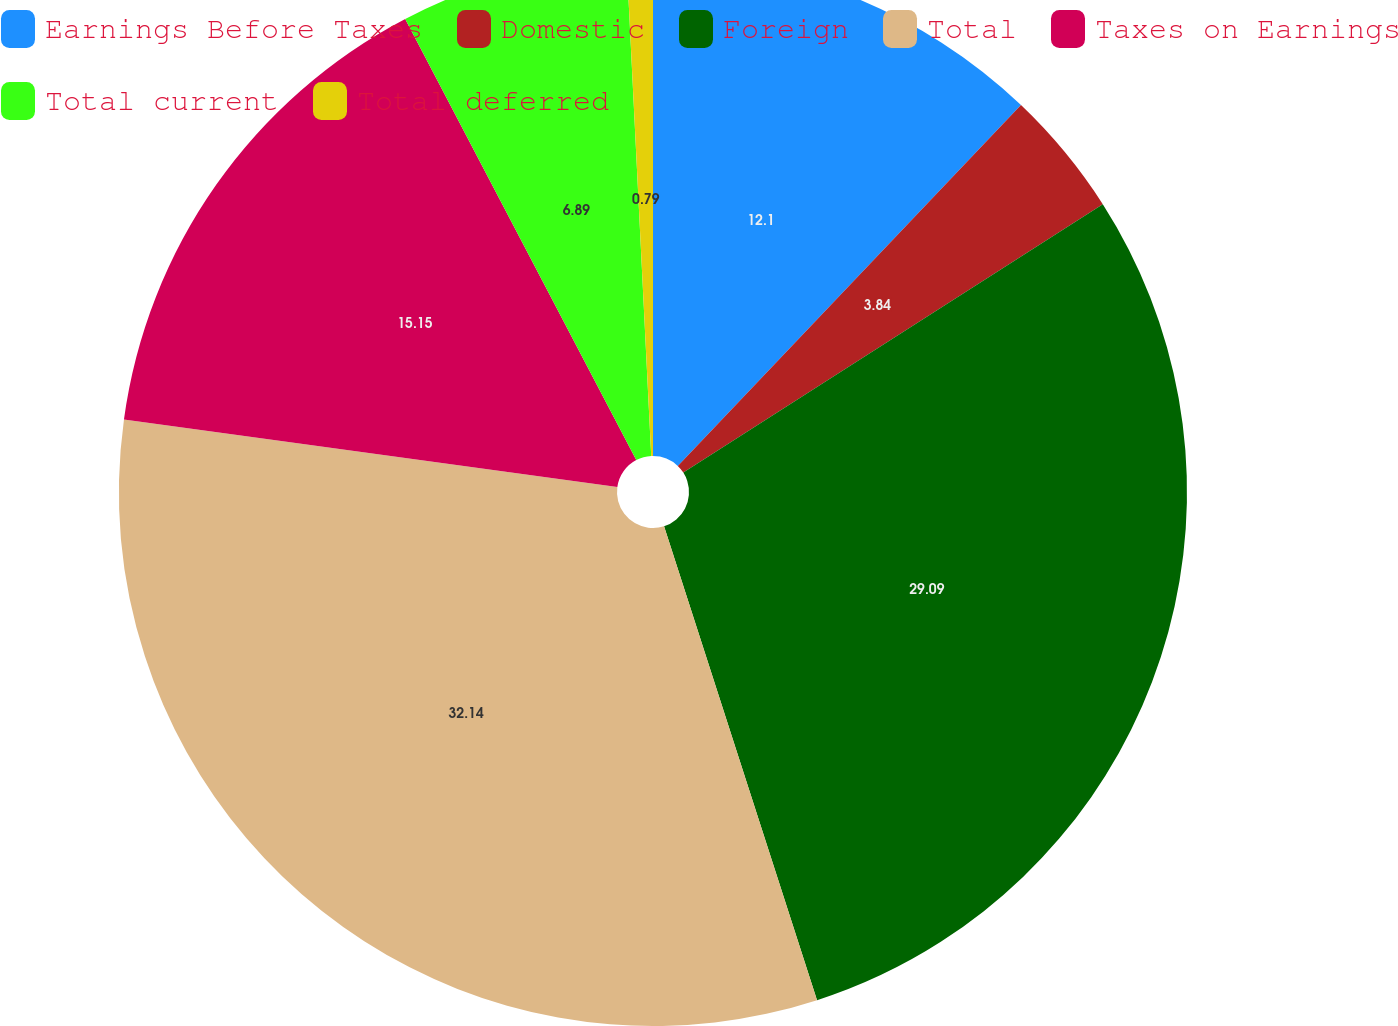<chart> <loc_0><loc_0><loc_500><loc_500><pie_chart><fcel>Earnings Before Taxes<fcel>Domestic<fcel>Foreign<fcel>Total<fcel>Taxes on Earnings<fcel>Total current<fcel>Total deferred<nl><fcel>12.1%<fcel>3.84%<fcel>29.09%<fcel>32.14%<fcel>15.15%<fcel>6.89%<fcel>0.79%<nl></chart> 